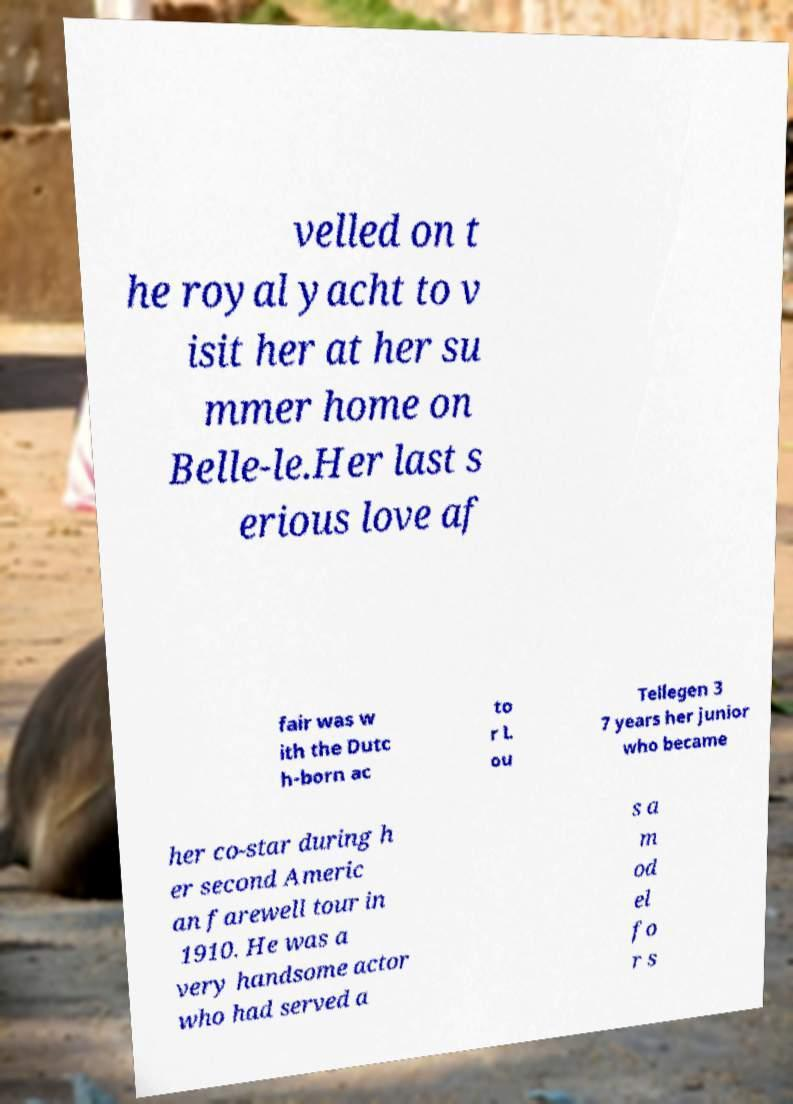There's text embedded in this image that I need extracted. Can you transcribe it verbatim? velled on t he royal yacht to v isit her at her su mmer home on Belle-le.Her last s erious love af fair was w ith the Dutc h-born ac to r L ou Tellegen 3 7 years her junior who became her co-star during h er second Americ an farewell tour in 1910. He was a very handsome actor who had served a s a m od el fo r s 